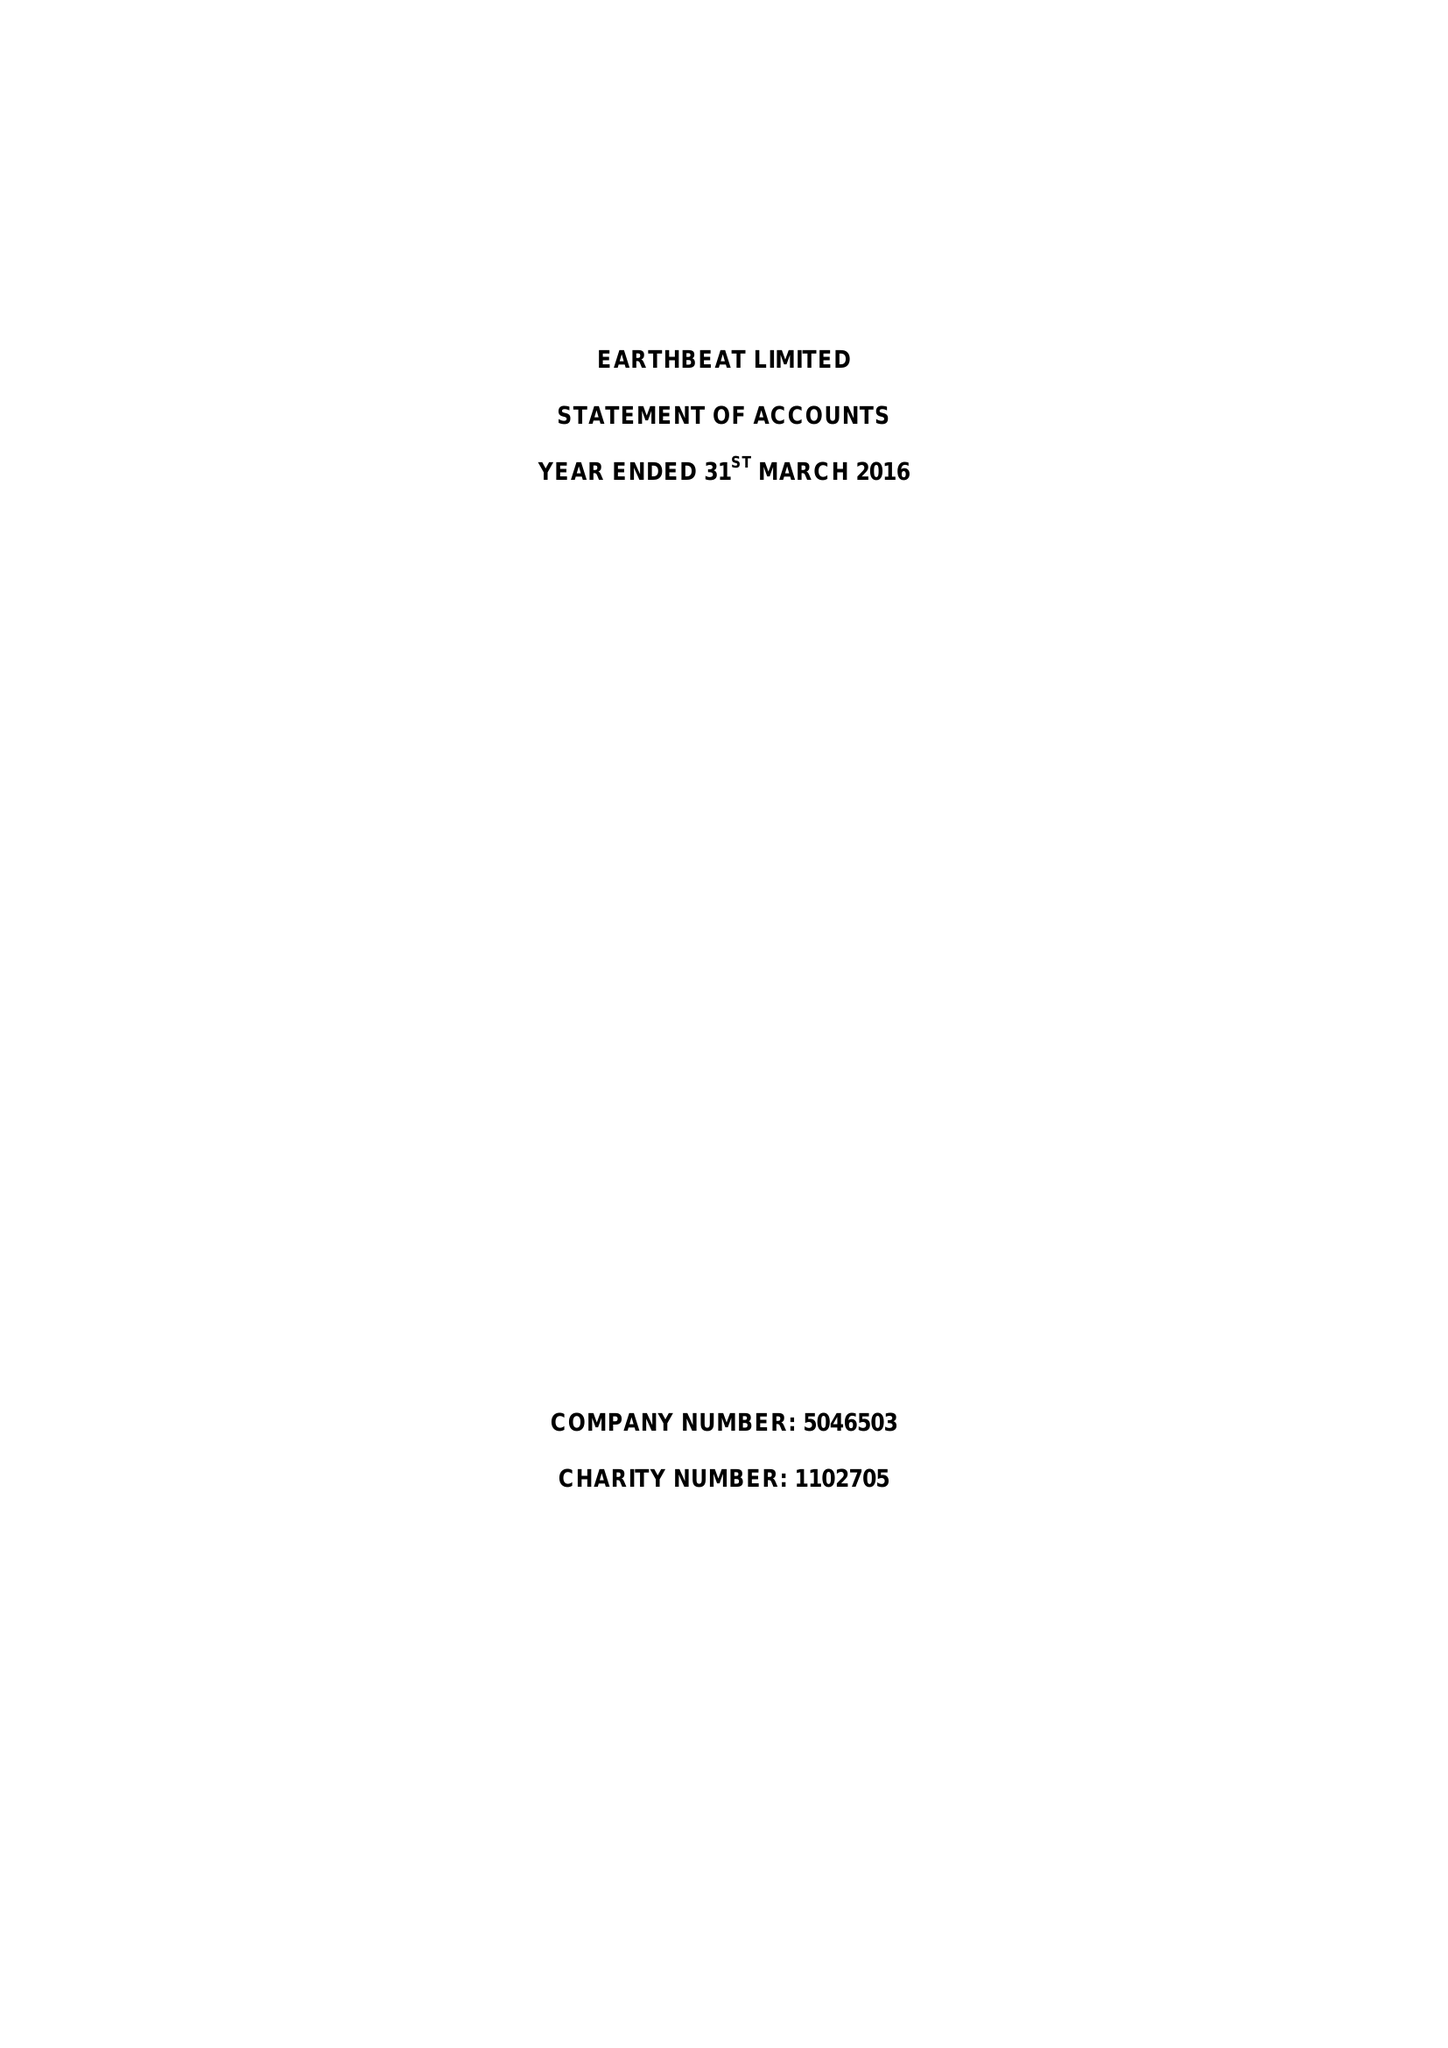What is the value for the charity_number?
Answer the question using a single word or phrase. 1102705 